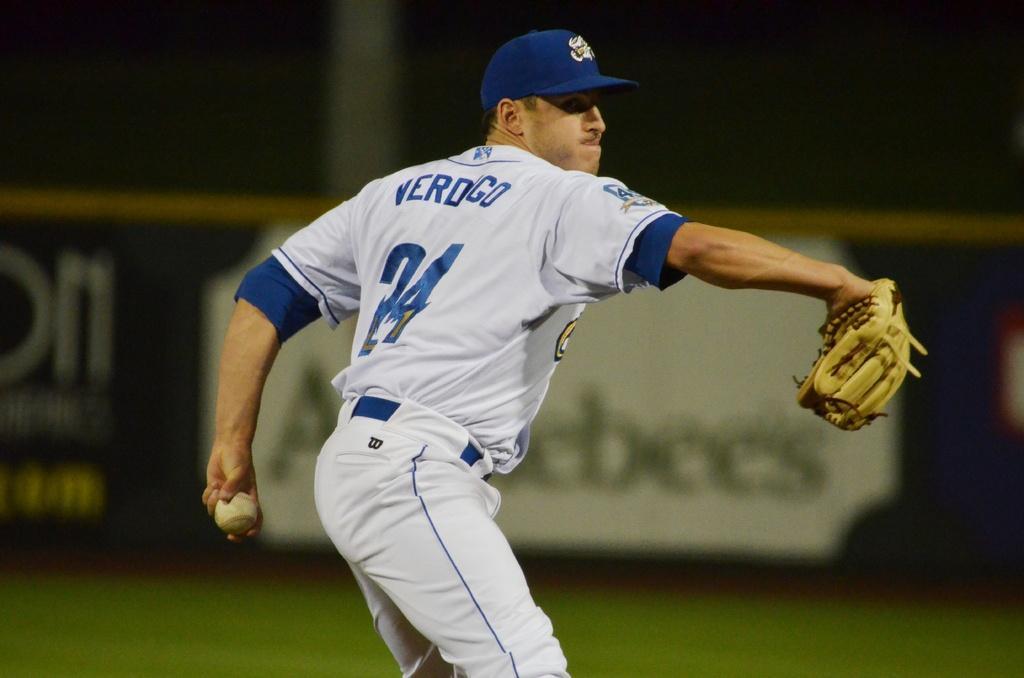How would you summarize this image in a sentence or two? In the image there is a man with white and blue dress is standing and there is a cap on his head. He is holding a ball in one hand and a glove in another hand. Behind him there is a blur background. 